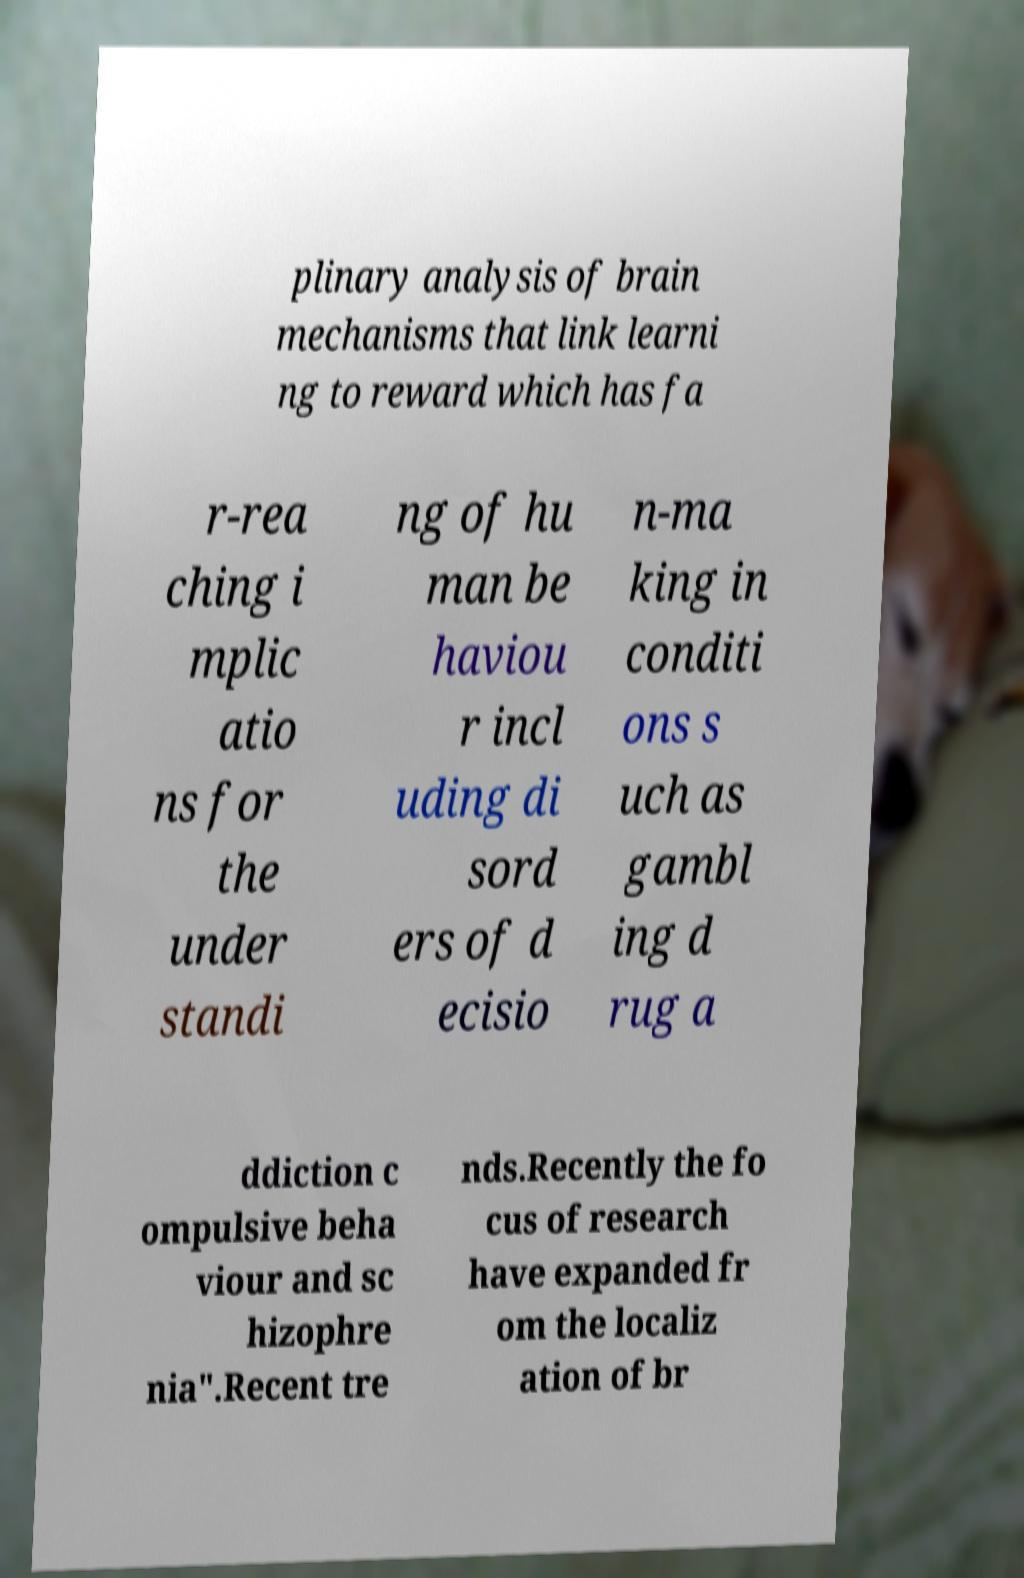Please read and relay the text visible in this image. What does it say? plinary analysis of brain mechanisms that link learni ng to reward which has fa r-rea ching i mplic atio ns for the under standi ng of hu man be haviou r incl uding di sord ers of d ecisio n-ma king in conditi ons s uch as gambl ing d rug a ddiction c ompulsive beha viour and sc hizophre nia".Recent tre nds.Recently the fo cus of research have expanded fr om the localiz ation of br 